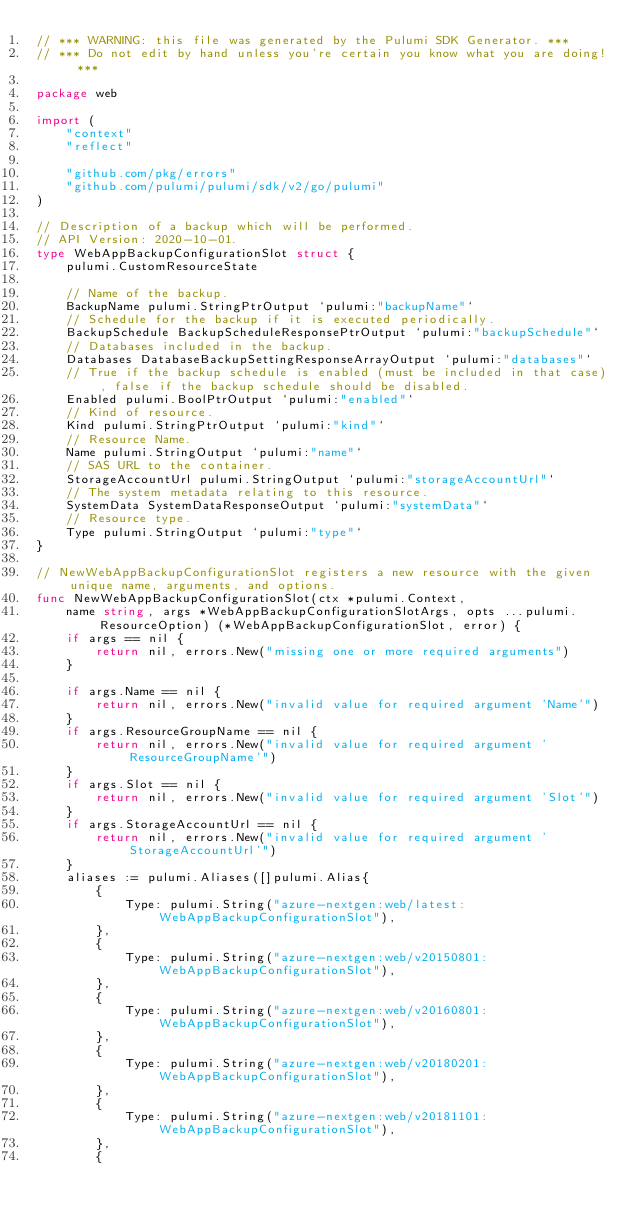Convert code to text. <code><loc_0><loc_0><loc_500><loc_500><_Go_>// *** WARNING: this file was generated by the Pulumi SDK Generator. ***
// *** Do not edit by hand unless you're certain you know what you are doing! ***

package web

import (
	"context"
	"reflect"

	"github.com/pkg/errors"
	"github.com/pulumi/pulumi/sdk/v2/go/pulumi"
)

// Description of a backup which will be performed.
// API Version: 2020-10-01.
type WebAppBackupConfigurationSlot struct {
	pulumi.CustomResourceState

	// Name of the backup.
	BackupName pulumi.StringPtrOutput `pulumi:"backupName"`
	// Schedule for the backup if it is executed periodically.
	BackupSchedule BackupScheduleResponsePtrOutput `pulumi:"backupSchedule"`
	// Databases included in the backup.
	Databases DatabaseBackupSettingResponseArrayOutput `pulumi:"databases"`
	// True if the backup schedule is enabled (must be included in that case), false if the backup schedule should be disabled.
	Enabled pulumi.BoolPtrOutput `pulumi:"enabled"`
	// Kind of resource.
	Kind pulumi.StringPtrOutput `pulumi:"kind"`
	// Resource Name.
	Name pulumi.StringOutput `pulumi:"name"`
	// SAS URL to the container.
	StorageAccountUrl pulumi.StringOutput `pulumi:"storageAccountUrl"`
	// The system metadata relating to this resource.
	SystemData SystemDataResponseOutput `pulumi:"systemData"`
	// Resource type.
	Type pulumi.StringOutput `pulumi:"type"`
}

// NewWebAppBackupConfigurationSlot registers a new resource with the given unique name, arguments, and options.
func NewWebAppBackupConfigurationSlot(ctx *pulumi.Context,
	name string, args *WebAppBackupConfigurationSlotArgs, opts ...pulumi.ResourceOption) (*WebAppBackupConfigurationSlot, error) {
	if args == nil {
		return nil, errors.New("missing one or more required arguments")
	}

	if args.Name == nil {
		return nil, errors.New("invalid value for required argument 'Name'")
	}
	if args.ResourceGroupName == nil {
		return nil, errors.New("invalid value for required argument 'ResourceGroupName'")
	}
	if args.Slot == nil {
		return nil, errors.New("invalid value for required argument 'Slot'")
	}
	if args.StorageAccountUrl == nil {
		return nil, errors.New("invalid value for required argument 'StorageAccountUrl'")
	}
	aliases := pulumi.Aliases([]pulumi.Alias{
		{
			Type: pulumi.String("azure-nextgen:web/latest:WebAppBackupConfigurationSlot"),
		},
		{
			Type: pulumi.String("azure-nextgen:web/v20150801:WebAppBackupConfigurationSlot"),
		},
		{
			Type: pulumi.String("azure-nextgen:web/v20160801:WebAppBackupConfigurationSlot"),
		},
		{
			Type: pulumi.String("azure-nextgen:web/v20180201:WebAppBackupConfigurationSlot"),
		},
		{
			Type: pulumi.String("azure-nextgen:web/v20181101:WebAppBackupConfigurationSlot"),
		},
		{</code> 